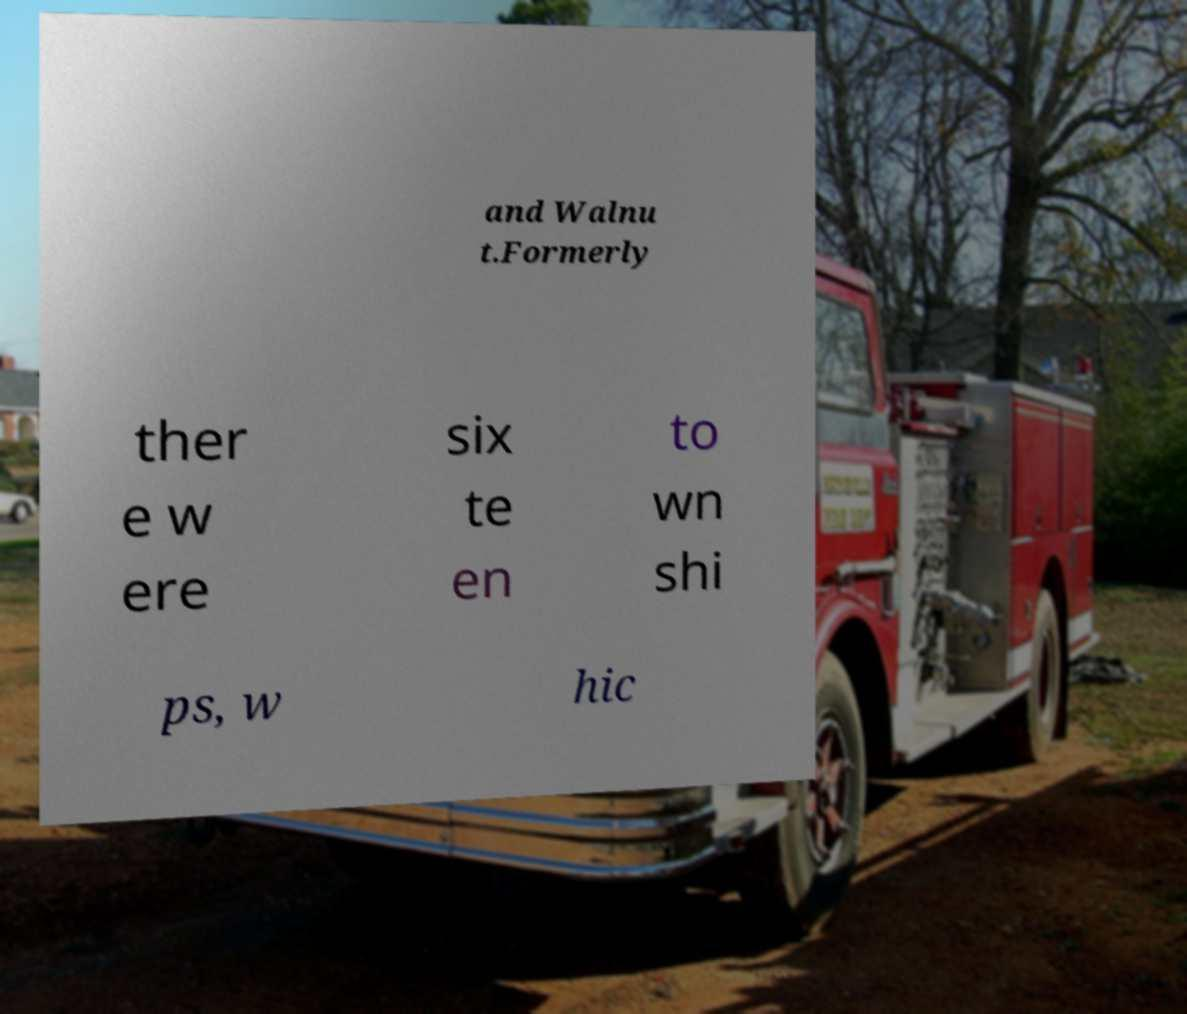Please identify and transcribe the text found in this image. and Walnu t.Formerly ther e w ere six te en to wn shi ps, w hic 